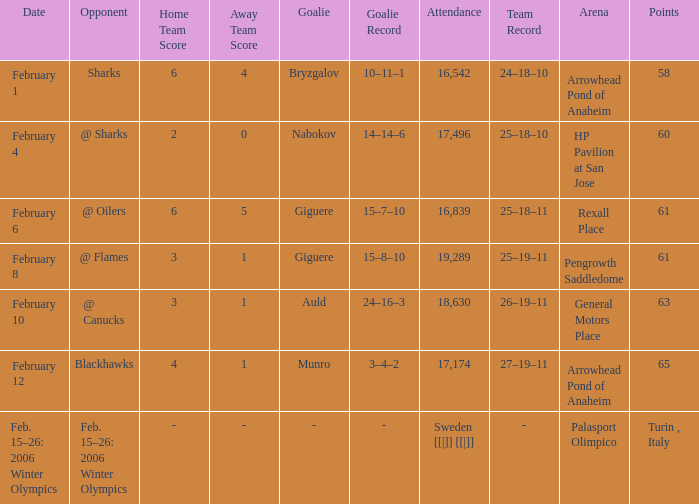With a 10-11-1 loss record for bryzgalov, what was the record at arrowhead pond of anaheim? 24–18–10. 